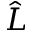<formula> <loc_0><loc_0><loc_500><loc_500>\hat { L }</formula> 